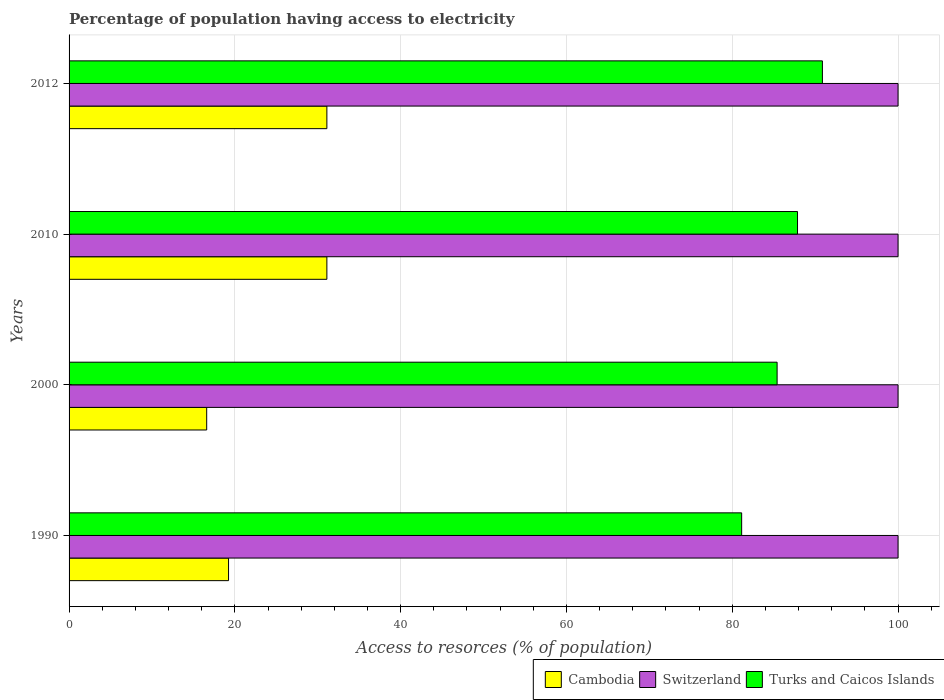Are the number of bars per tick equal to the number of legend labels?
Keep it short and to the point. Yes. Are the number of bars on each tick of the Y-axis equal?
Your answer should be very brief. Yes. How many bars are there on the 3rd tick from the top?
Your answer should be compact. 3. What is the label of the 4th group of bars from the top?
Give a very brief answer. 1990. What is the percentage of population having access to electricity in Turks and Caicos Islands in 2000?
Provide a short and direct response. 85.41. Across all years, what is the maximum percentage of population having access to electricity in Switzerland?
Offer a very short reply. 100. In which year was the percentage of population having access to electricity in Turks and Caicos Islands maximum?
Offer a very short reply. 2012. What is the total percentage of population having access to electricity in Turks and Caicos Islands in the graph?
Keep it short and to the point. 345.3. What is the difference between the percentage of population having access to electricity in Switzerland in 1990 and that in 2012?
Your answer should be very brief. 0. What is the difference between the percentage of population having access to electricity in Switzerland in 1990 and the percentage of population having access to electricity in Cambodia in 2012?
Provide a short and direct response. 68.9. In the year 2012, what is the difference between the percentage of population having access to electricity in Cambodia and percentage of population having access to electricity in Turks and Caicos Islands?
Give a very brief answer. -59.78. In how many years, is the percentage of population having access to electricity in Cambodia greater than 68 %?
Offer a terse response. 0. What is the ratio of the percentage of population having access to electricity in Switzerland in 1990 to that in 2000?
Offer a terse response. 1. What is the difference between the highest and the second highest percentage of population having access to electricity in Switzerland?
Provide a succinct answer. 0. What is the difference between the highest and the lowest percentage of population having access to electricity in Turks and Caicos Islands?
Make the answer very short. 9.74. In how many years, is the percentage of population having access to electricity in Cambodia greater than the average percentage of population having access to electricity in Cambodia taken over all years?
Give a very brief answer. 2. Is the sum of the percentage of population having access to electricity in Cambodia in 2010 and 2012 greater than the maximum percentage of population having access to electricity in Switzerland across all years?
Offer a very short reply. No. What does the 3rd bar from the top in 2010 represents?
Offer a very short reply. Cambodia. What does the 2nd bar from the bottom in 1990 represents?
Your answer should be compact. Switzerland. Is it the case that in every year, the sum of the percentage of population having access to electricity in Switzerland and percentage of population having access to electricity in Cambodia is greater than the percentage of population having access to electricity in Turks and Caicos Islands?
Provide a short and direct response. Yes. How many years are there in the graph?
Your answer should be compact. 4. Does the graph contain grids?
Provide a short and direct response. Yes. Where does the legend appear in the graph?
Provide a short and direct response. Bottom right. How are the legend labels stacked?
Make the answer very short. Horizontal. What is the title of the graph?
Keep it short and to the point. Percentage of population having access to electricity. What is the label or title of the X-axis?
Your answer should be very brief. Access to resorces (% of population). What is the label or title of the Y-axis?
Keep it short and to the point. Years. What is the Access to resorces (% of population) in Cambodia in 1990?
Keep it short and to the point. 19.24. What is the Access to resorces (% of population) of Switzerland in 1990?
Provide a short and direct response. 100. What is the Access to resorces (% of population) of Turks and Caicos Islands in 1990?
Offer a very short reply. 81.14. What is the Access to resorces (% of population) of Turks and Caicos Islands in 2000?
Make the answer very short. 85.41. What is the Access to resorces (% of population) of Cambodia in 2010?
Give a very brief answer. 31.1. What is the Access to resorces (% of population) in Turks and Caicos Islands in 2010?
Offer a terse response. 87.87. What is the Access to resorces (% of population) of Cambodia in 2012?
Ensure brevity in your answer.  31.1. What is the Access to resorces (% of population) in Switzerland in 2012?
Offer a terse response. 100. What is the Access to resorces (% of population) in Turks and Caicos Islands in 2012?
Give a very brief answer. 90.88. Across all years, what is the maximum Access to resorces (% of population) of Cambodia?
Your response must be concise. 31.1. Across all years, what is the maximum Access to resorces (% of population) in Switzerland?
Provide a short and direct response. 100. Across all years, what is the maximum Access to resorces (% of population) of Turks and Caicos Islands?
Your response must be concise. 90.88. Across all years, what is the minimum Access to resorces (% of population) in Turks and Caicos Islands?
Keep it short and to the point. 81.14. What is the total Access to resorces (% of population) of Cambodia in the graph?
Provide a short and direct response. 98.04. What is the total Access to resorces (% of population) in Switzerland in the graph?
Offer a terse response. 400. What is the total Access to resorces (% of population) in Turks and Caicos Islands in the graph?
Your response must be concise. 345.3. What is the difference between the Access to resorces (% of population) in Cambodia in 1990 and that in 2000?
Make the answer very short. 2.64. What is the difference between the Access to resorces (% of population) of Turks and Caicos Islands in 1990 and that in 2000?
Ensure brevity in your answer.  -4.28. What is the difference between the Access to resorces (% of population) of Cambodia in 1990 and that in 2010?
Provide a short and direct response. -11.86. What is the difference between the Access to resorces (% of population) in Turks and Caicos Islands in 1990 and that in 2010?
Keep it short and to the point. -6.74. What is the difference between the Access to resorces (% of population) of Cambodia in 1990 and that in 2012?
Provide a succinct answer. -11.86. What is the difference between the Access to resorces (% of population) in Switzerland in 1990 and that in 2012?
Offer a very short reply. 0. What is the difference between the Access to resorces (% of population) of Turks and Caicos Islands in 1990 and that in 2012?
Provide a short and direct response. -9.74. What is the difference between the Access to resorces (% of population) in Switzerland in 2000 and that in 2010?
Your answer should be compact. 0. What is the difference between the Access to resorces (% of population) in Turks and Caicos Islands in 2000 and that in 2010?
Give a very brief answer. -2.46. What is the difference between the Access to resorces (% of population) of Cambodia in 2000 and that in 2012?
Make the answer very short. -14.5. What is the difference between the Access to resorces (% of population) in Turks and Caicos Islands in 2000 and that in 2012?
Offer a terse response. -5.46. What is the difference between the Access to resorces (% of population) in Switzerland in 2010 and that in 2012?
Offer a very short reply. 0. What is the difference between the Access to resorces (% of population) of Turks and Caicos Islands in 2010 and that in 2012?
Offer a very short reply. -3. What is the difference between the Access to resorces (% of population) in Cambodia in 1990 and the Access to resorces (% of population) in Switzerland in 2000?
Keep it short and to the point. -80.76. What is the difference between the Access to resorces (% of population) of Cambodia in 1990 and the Access to resorces (% of population) of Turks and Caicos Islands in 2000?
Ensure brevity in your answer.  -66.17. What is the difference between the Access to resorces (% of population) in Switzerland in 1990 and the Access to resorces (% of population) in Turks and Caicos Islands in 2000?
Give a very brief answer. 14.59. What is the difference between the Access to resorces (% of population) of Cambodia in 1990 and the Access to resorces (% of population) of Switzerland in 2010?
Ensure brevity in your answer.  -80.76. What is the difference between the Access to resorces (% of population) of Cambodia in 1990 and the Access to resorces (% of population) of Turks and Caicos Islands in 2010?
Offer a very short reply. -68.64. What is the difference between the Access to resorces (% of population) in Switzerland in 1990 and the Access to resorces (% of population) in Turks and Caicos Islands in 2010?
Your answer should be compact. 12.13. What is the difference between the Access to resorces (% of population) in Cambodia in 1990 and the Access to resorces (% of population) in Switzerland in 2012?
Keep it short and to the point. -80.76. What is the difference between the Access to resorces (% of population) of Cambodia in 1990 and the Access to resorces (% of population) of Turks and Caicos Islands in 2012?
Give a very brief answer. -71.64. What is the difference between the Access to resorces (% of population) of Switzerland in 1990 and the Access to resorces (% of population) of Turks and Caicos Islands in 2012?
Offer a terse response. 9.12. What is the difference between the Access to resorces (% of population) in Cambodia in 2000 and the Access to resorces (% of population) in Switzerland in 2010?
Your answer should be very brief. -83.4. What is the difference between the Access to resorces (% of population) of Cambodia in 2000 and the Access to resorces (% of population) of Turks and Caicos Islands in 2010?
Keep it short and to the point. -71.27. What is the difference between the Access to resorces (% of population) of Switzerland in 2000 and the Access to resorces (% of population) of Turks and Caicos Islands in 2010?
Ensure brevity in your answer.  12.13. What is the difference between the Access to resorces (% of population) of Cambodia in 2000 and the Access to resorces (% of population) of Switzerland in 2012?
Give a very brief answer. -83.4. What is the difference between the Access to resorces (% of population) of Cambodia in 2000 and the Access to resorces (% of population) of Turks and Caicos Islands in 2012?
Provide a short and direct response. -74.28. What is the difference between the Access to resorces (% of population) of Switzerland in 2000 and the Access to resorces (% of population) of Turks and Caicos Islands in 2012?
Offer a terse response. 9.12. What is the difference between the Access to resorces (% of population) of Cambodia in 2010 and the Access to resorces (% of population) of Switzerland in 2012?
Ensure brevity in your answer.  -68.9. What is the difference between the Access to resorces (% of population) of Cambodia in 2010 and the Access to resorces (% of population) of Turks and Caicos Islands in 2012?
Offer a terse response. -59.78. What is the difference between the Access to resorces (% of population) in Switzerland in 2010 and the Access to resorces (% of population) in Turks and Caicos Islands in 2012?
Give a very brief answer. 9.12. What is the average Access to resorces (% of population) of Cambodia per year?
Offer a very short reply. 24.51. What is the average Access to resorces (% of population) in Turks and Caicos Islands per year?
Give a very brief answer. 86.32. In the year 1990, what is the difference between the Access to resorces (% of population) of Cambodia and Access to resorces (% of population) of Switzerland?
Offer a very short reply. -80.76. In the year 1990, what is the difference between the Access to resorces (% of population) of Cambodia and Access to resorces (% of population) of Turks and Caicos Islands?
Your answer should be compact. -61.9. In the year 1990, what is the difference between the Access to resorces (% of population) of Switzerland and Access to resorces (% of population) of Turks and Caicos Islands?
Give a very brief answer. 18.86. In the year 2000, what is the difference between the Access to resorces (% of population) of Cambodia and Access to resorces (% of population) of Switzerland?
Your answer should be compact. -83.4. In the year 2000, what is the difference between the Access to resorces (% of population) in Cambodia and Access to resorces (% of population) in Turks and Caicos Islands?
Make the answer very short. -68.81. In the year 2000, what is the difference between the Access to resorces (% of population) of Switzerland and Access to resorces (% of population) of Turks and Caicos Islands?
Your answer should be very brief. 14.59. In the year 2010, what is the difference between the Access to resorces (% of population) in Cambodia and Access to resorces (% of population) in Switzerland?
Your answer should be very brief. -68.9. In the year 2010, what is the difference between the Access to resorces (% of population) of Cambodia and Access to resorces (% of population) of Turks and Caicos Islands?
Ensure brevity in your answer.  -56.77. In the year 2010, what is the difference between the Access to resorces (% of population) of Switzerland and Access to resorces (% of population) of Turks and Caicos Islands?
Provide a short and direct response. 12.13. In the year 2012, what is the difference between the Access to resorces (% of population) of Cambodia and Access to resorces (% of population) of Switzerland?
Make the answer very short. -68.9. In the year 2012, what is the difference between the Access to resorces (% of population) in Cambodia and Access to resorces (% of population) in Turks and Caicos Islands?
Offer a terse response. -59.78. In the year 2012, what is the difference between the Access to resorces (% of population) in Switzerland and Access to resorces (% of population) in Turks and Caicos Islands?
Your response must be concise. 9.12. What is the ratio of the Access to resorces (% of population) in Cambodia in 1990 to that in 2000?
Your answer should be compact. 1.16. What is the ratio of the Access to resorces (% of population) of Switzerland in 1990 to that in 2000?
Keep it short and to the point. 1. What is the ratio of the Access to resorces (% of population) in Turks and Caicos Islands in 1990 to that in 2000?
Keep it short and to the point. 0.95. What is the ratio of the Access to resorces (% of population) of Cambodia in 1990 to that in 2010?
Provide a succinct answer. 0.62. What is the ratio of the Access to resorces (% of population) in Switzerland in 1990 to that in 2010?
Provide a short and direct response. 1. What is the ratio of the Access to resorces (% of population) of Turks and Caicos Islands in 1990 to that in 2010?
Make the answer very short. 0.92. What is the ratio of the Access to resorces (% of population) of Cambodia in 1990 to that in 2012?
Ensure brevity in your answer.  0.62. What is the ratio of the Access to resorces (% of population) in Switzerland in 1990 to that in 2012?
Ensure brevity in your answer.  1. What is the ratio of the Access to resorces (% of population) in Turks and Caicos Islands in 1990 to that in 2012?
Provide a short and direct response. 0.89. What is the ratio of the Access to resorces (% of population) of Cambodia in 2000 to that in 2010?
Your response must be concise. 0.53. What is the ratio of the Access to resorces (% of population) of Cambodia in 2000 to that in 2012?
Ensure brevity in your answer.  0.53. What is the ratio of the Access to resorces (% of population) in Switzerland in 2000 to that in 2012?
Offer a terse response. 1. What is the ratio of the Access to resorces (% of population) in Turks and Caicos Islands in 2000 to that in 2012?
Your response must be concise. 0.94. What is the difference between the highest and the second highest Access to resorces (% of population) in Turks and Caicos Islands?
Keep it short and to the point. 3. What is the difference between the highest and the lowest Access to resorces (% of population) in Turks and Caicos Islands?
Your answer should be compact. 9.74. 